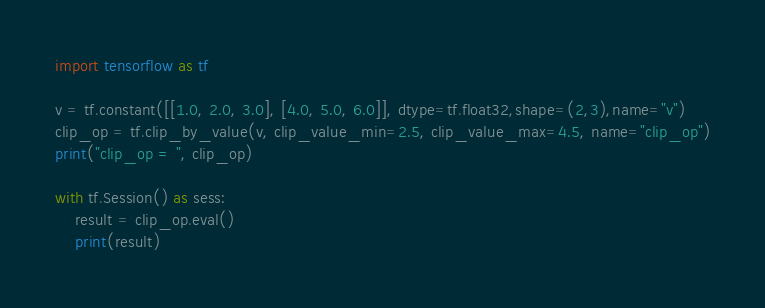<code> <loc_0><loc_0><loc_500><loc_500><_Python_>import tensorflow as tf

v = tf.constant([[1.0, 2.0, 3.0], [4.0, 5.0, 6.0]], dtype=tf.float32,shape=(2,3),name="v")
clip_op = tf.clip_by_value(v, clip_value_min=2.5, clip_value_max=4.5, name="clip_op")
print("clip_op = ", clip_op)

with tf.Session() as sess:
    result = clip_op.eval()
    print(result)</code> 